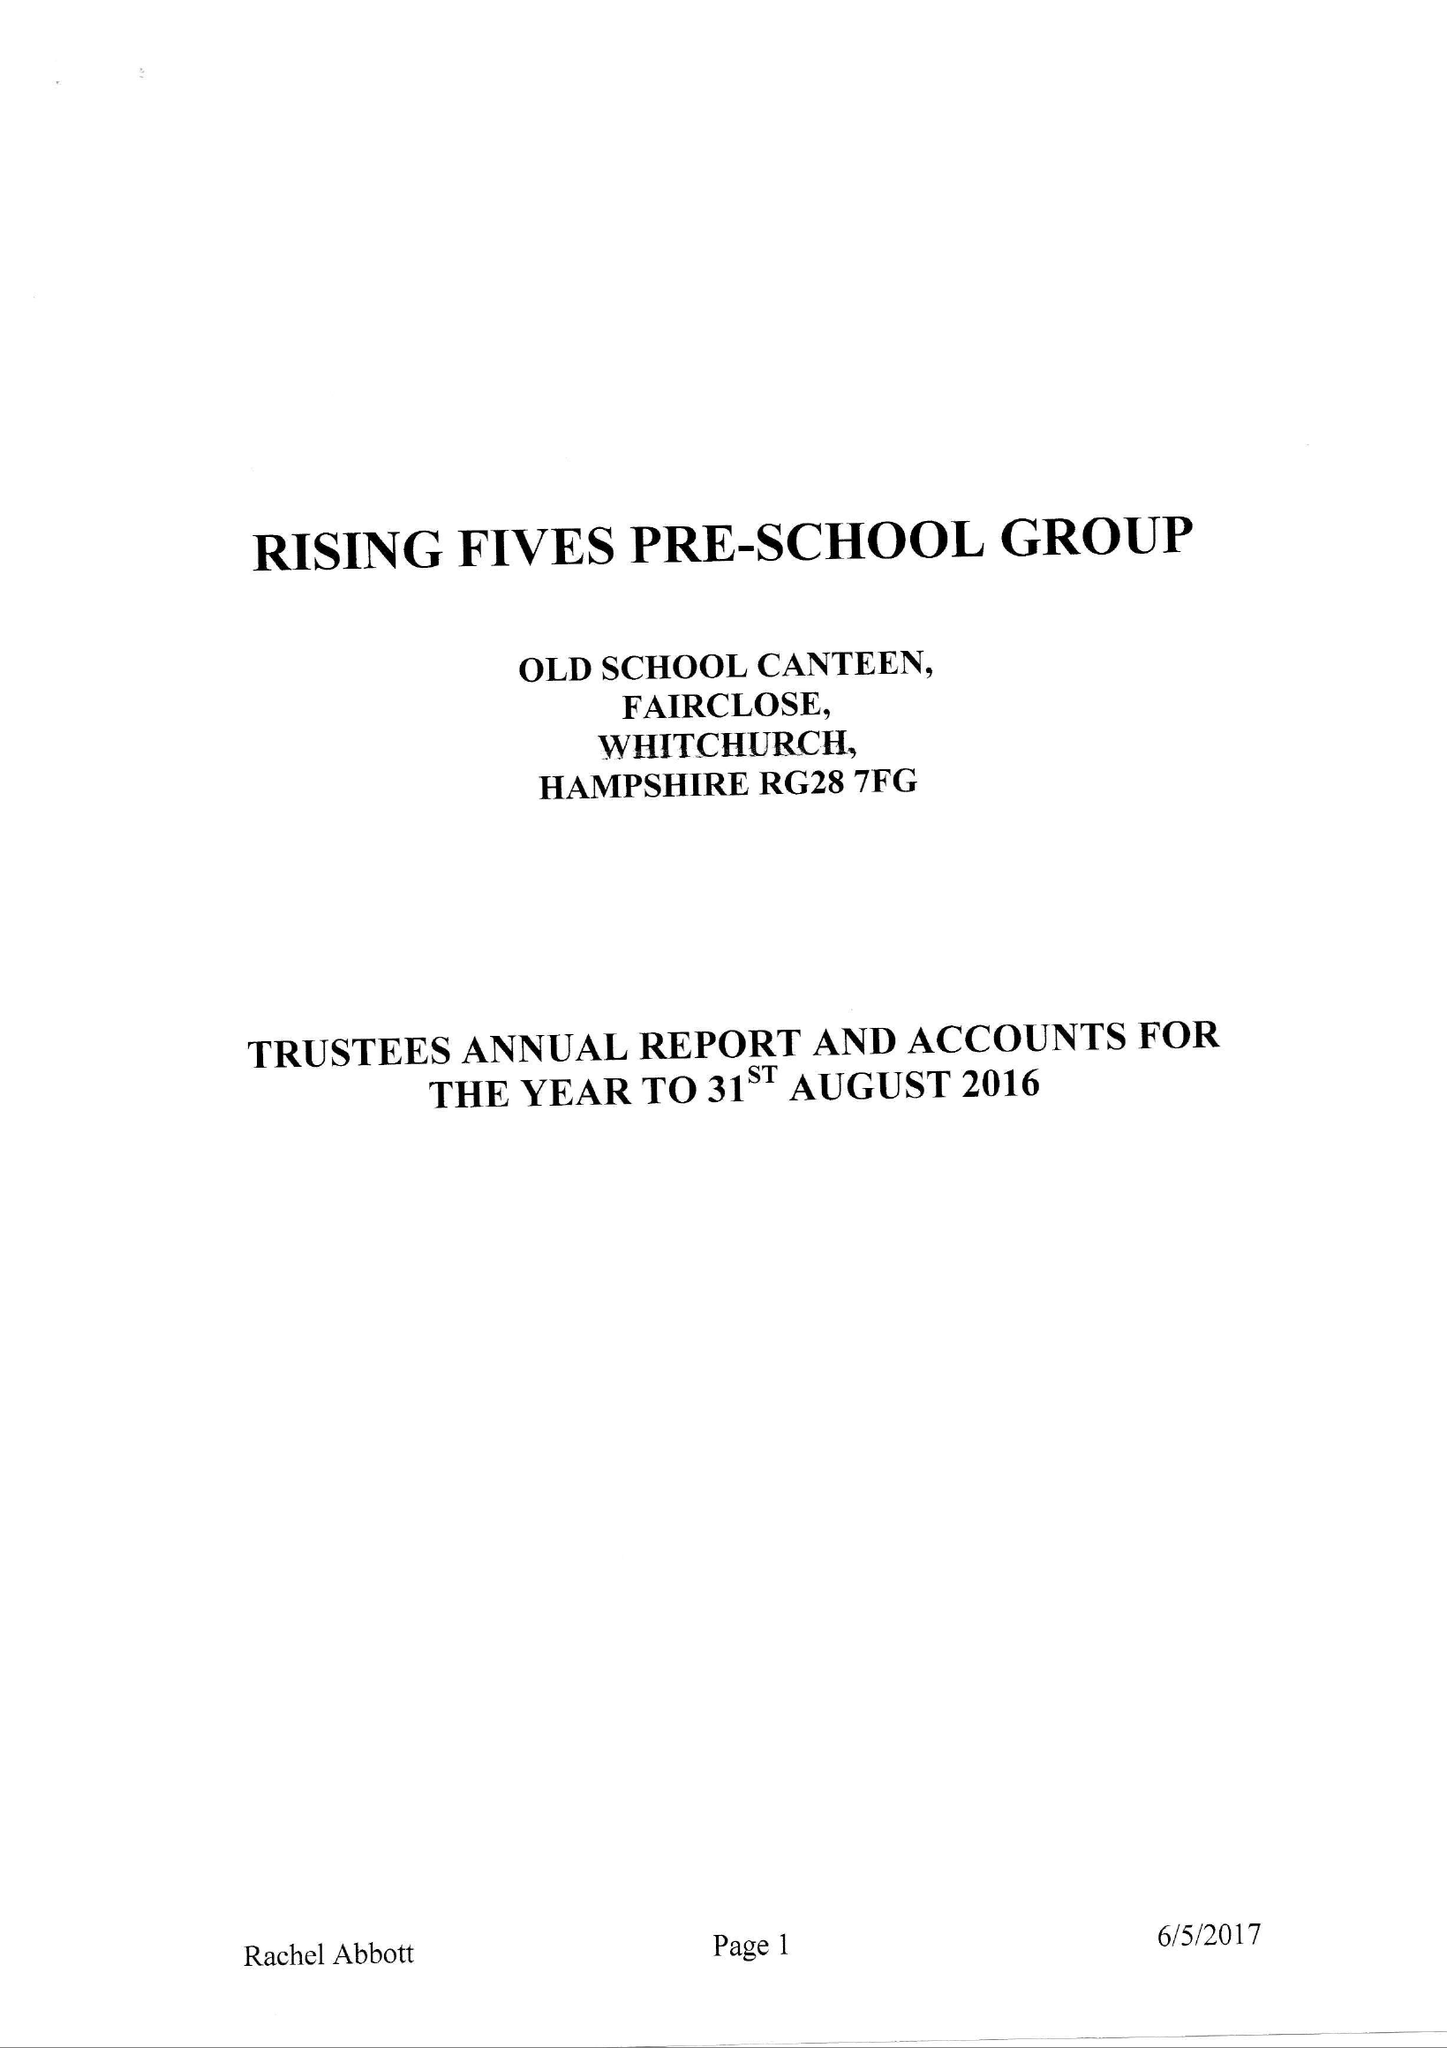What is the value for the spending_annually_in_british_pounds?
Answer the question using a single word or phrase. 90066.00 